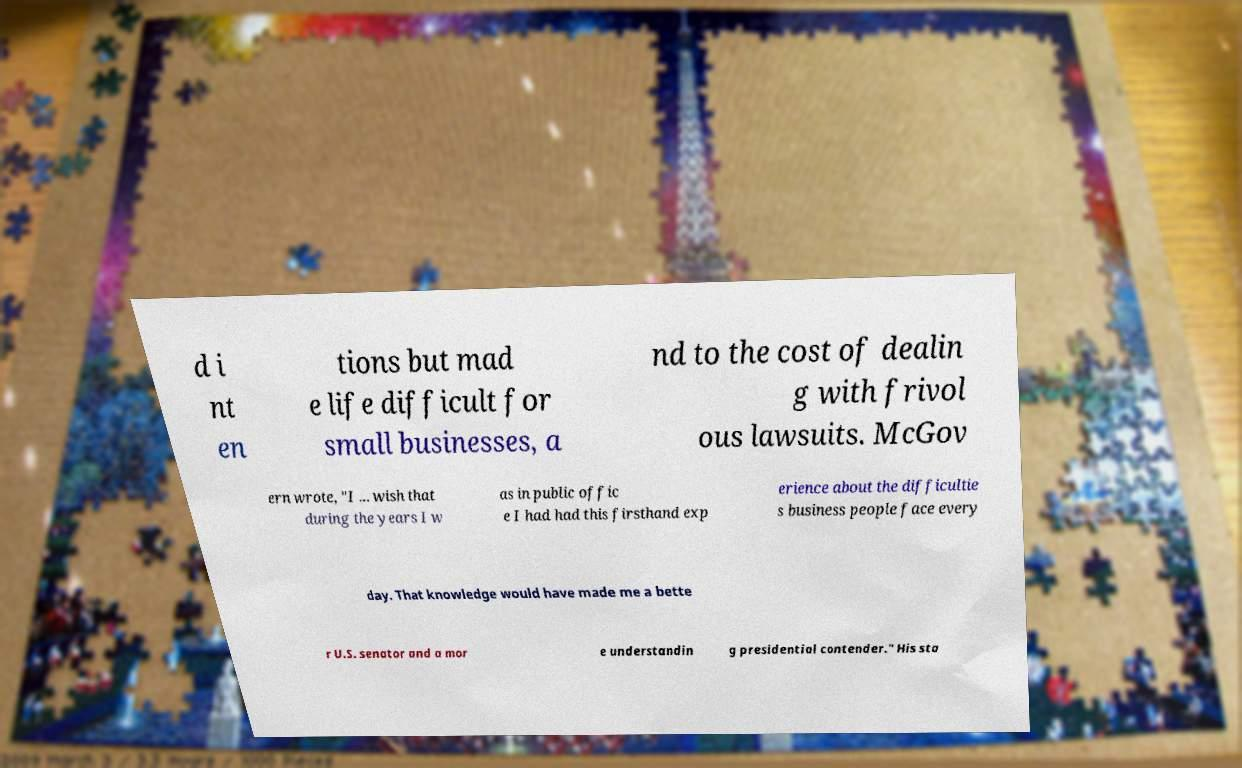There's text embedded in this image that I need extracted. Can you transcribe it verbatim? d i nt en tions but mad e life difficult for small businesses, a nd to the cost of dealin g with frivol ous lawsuits. McGov ern wrote, "I ... wish that during the years I w as in public offic e I had had this firsthand exp erience about the difficultie s business people face every day. That knowledge would have made me a bette r U.S. senator and a mor e understandin g presidential contender." His sta 